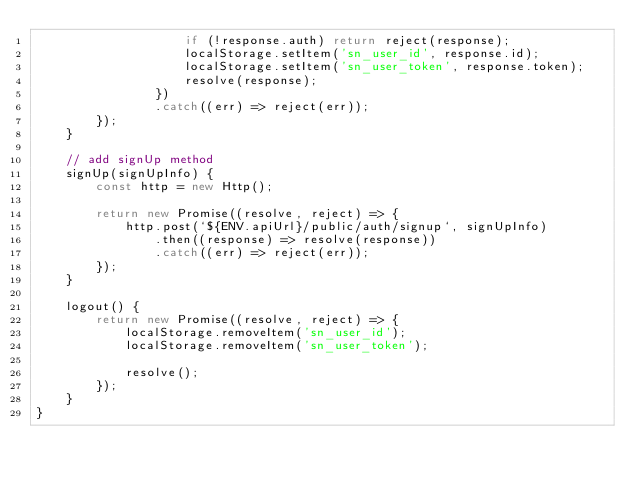Convert code to text. <code><loc_0><loc_0><loc_500><loc_500><_JavaScript_>                    if (!response.auth) return reject(response); 
                    localStorage.setItem('sn_user_id', response.id);
                    localStorage.setItem('sn_user_token', response.token);
                    resolve(response);
                })
                .catch((err) => reject(err));
        });
    }

    // add signUp method
    signUp(signUpInfo) {
        const http = new Http();

        return new Promise((resolve, reject) => {
            http.post(`${ENV.apiUrl}/public/auth/signup`, signUpInfo)
                .then((response) => resolve(response))
                .catch((err) => reject(err));
        });
    }

    logout() {
        return new Promise((resolve, reject) => {
            localStorage.removeItem('sn_user_id');
            localStorage.removeItem('sn_user_token');

            resolve();
        }); 
    }
}
</code> 